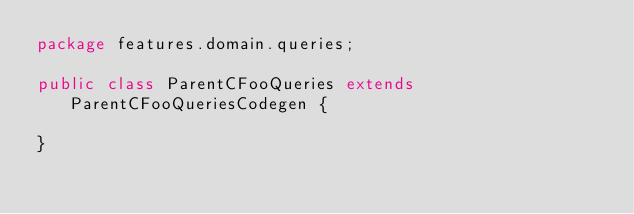<code> <loc_0><loc_0><loc_500><loc_500><_Java_>package features.domain.queries;

public class ParentCFooQueries extends ParentCFooQueriesCodegen {

}
</code> 